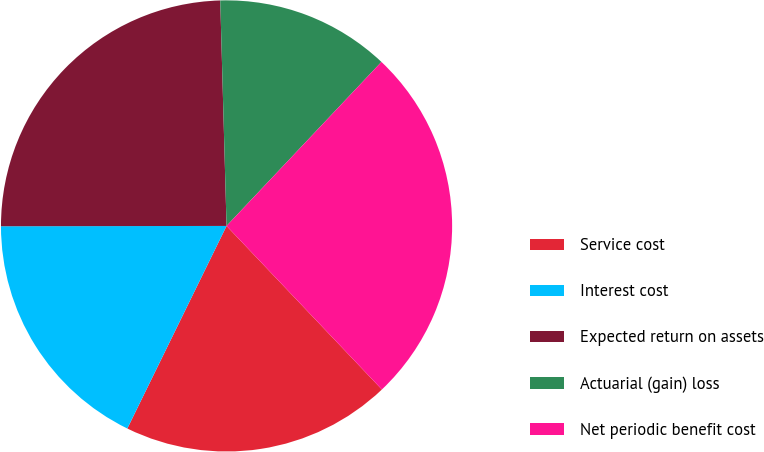<chart> <loc_0><loc_0><loc_500><loc_500><pie_chart><fcel>Service cost<fcel>Interest cost<fcel>Expected return on assets<fcel>Actuarial (gain) loss<fcel>Net periodic benefit cost<nl><fcel>19.34%<fcel>17.73%<fcel>24.58%<fcel>12.49%<fcel>25.87%<nl></chart> 